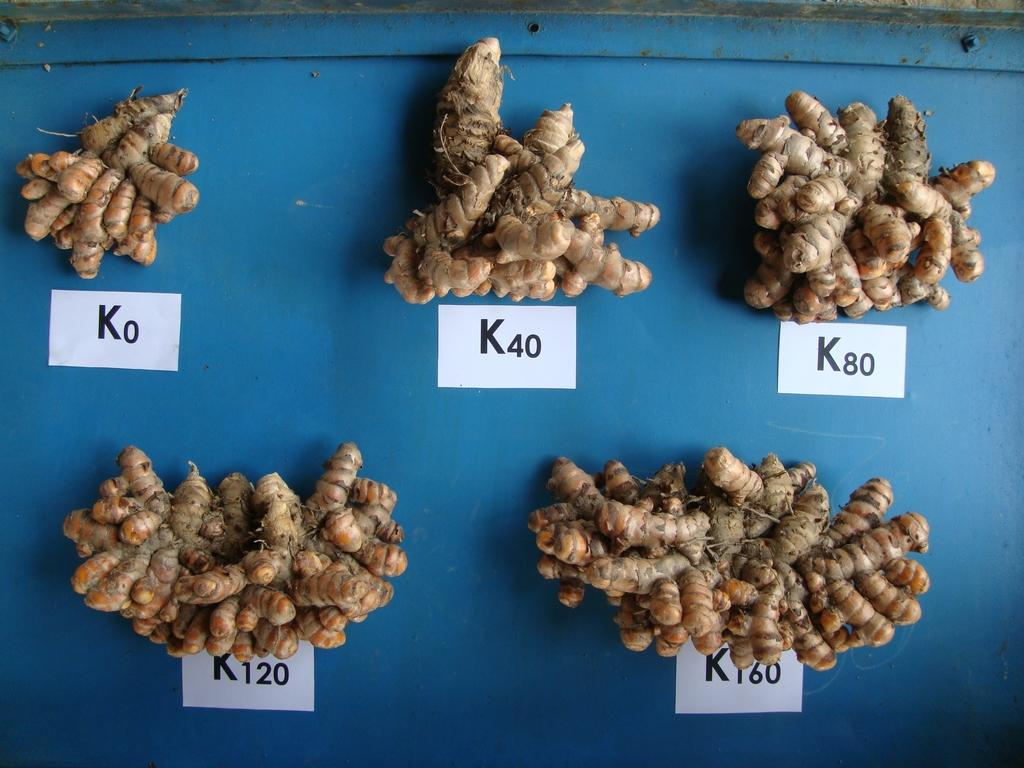What type of food item is present in the image? There are raw turmeric roots in the image. What else can be seen in the image besides the turmeric roots? There is a piece of paper with letters in the image. Where is the piece of paper placed in the image? The piece of paper is placed on an object. What type of selection does the aunt make in the image? There is no mention of an aunt or any selection in the image. 